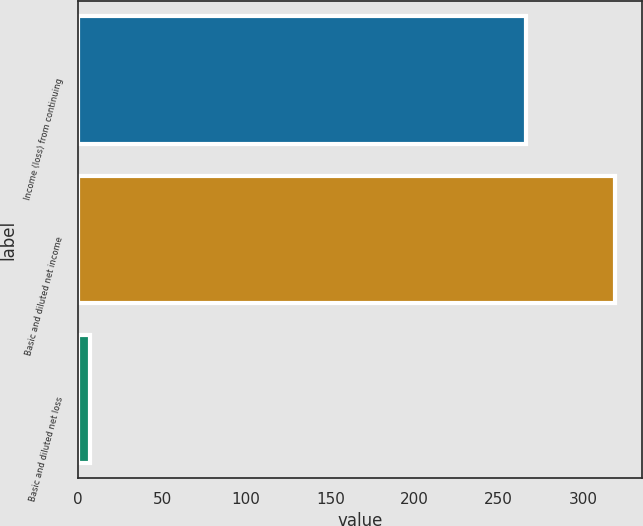<chart> <loc_0><loc_0><loc_500><loc_500><bar_chart><fcel>Income (loss) from continuing<fcel>Basic and diluted net income<fcel>Basic and diluted net loss<nl><fcel>266<fcel>319.2<fcel>7<nl></chart> 